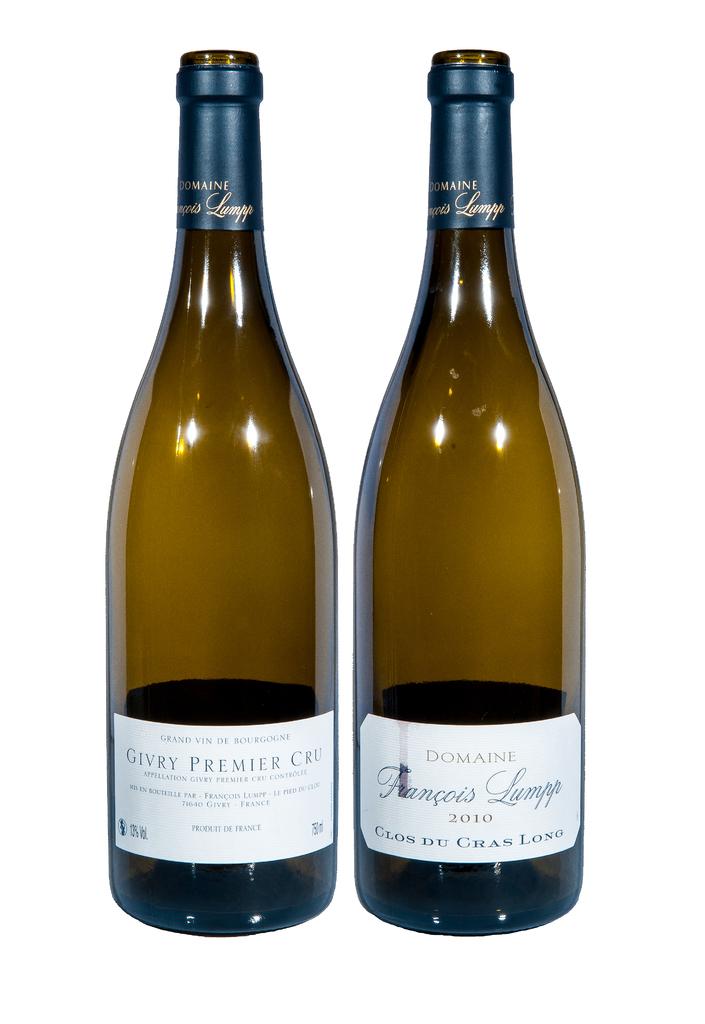What year is the right drink from?
Your answer should be very brief. 2010. 